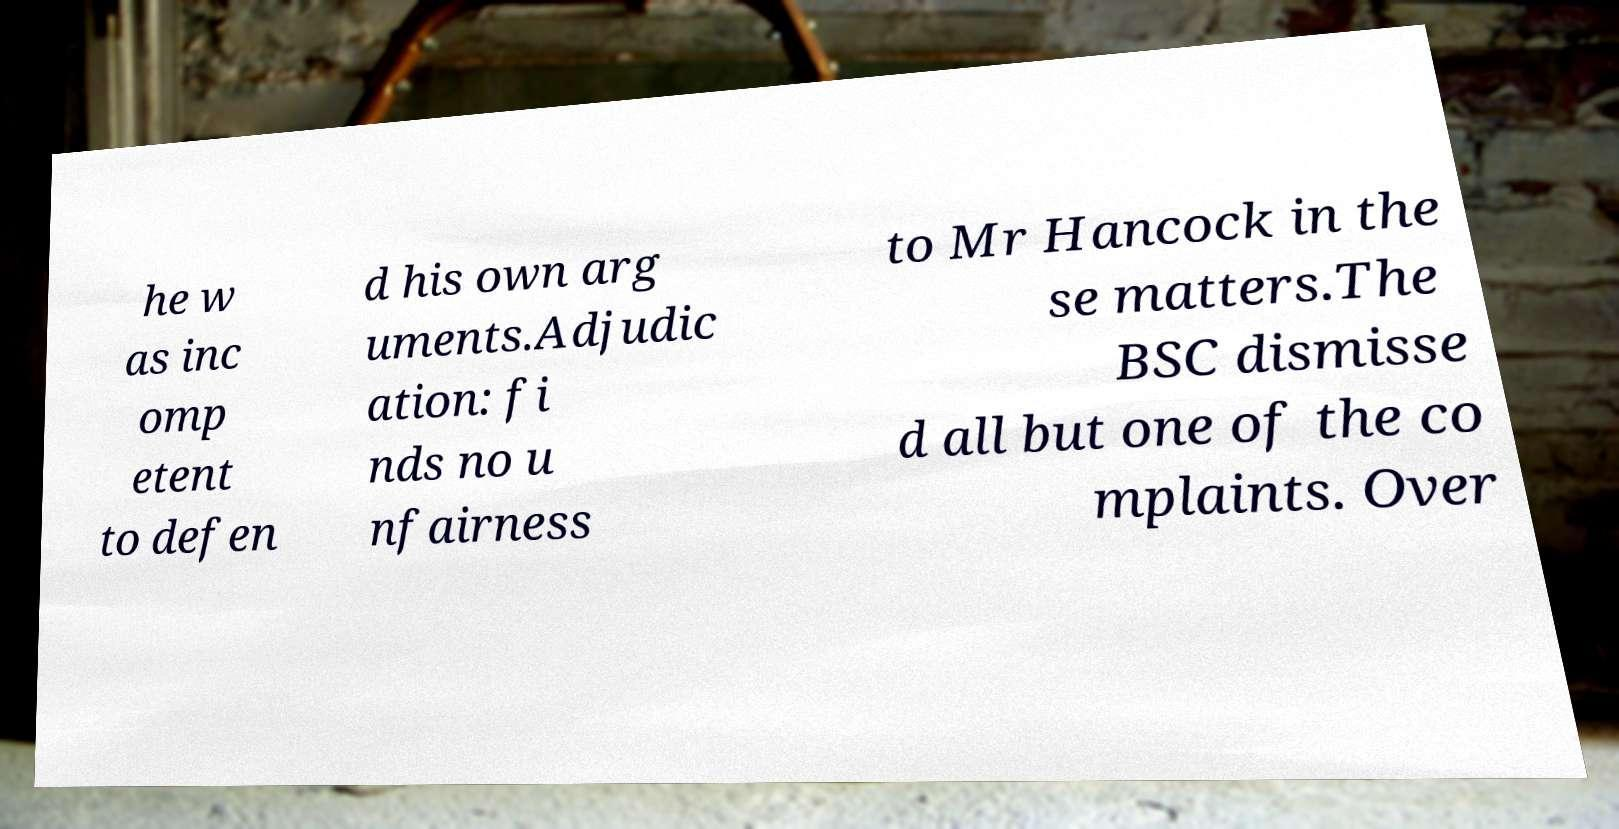Could you assist in decoding the text presented in this image and type it out clearly? he w as inc omp etent to defen d his own arg uments.Adjudic ation: fi nds no u nfairness to Mr Hancock in the se matters.The BSC dismisse d all but one of the co mplaints. Over 